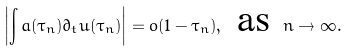Convert formula to latex. <formula><loc_0><loc_0><loc_500><loc_500>\left | \int a ( \tau _ { n } ) \partial _ { t } u ( \tau _ { n } ) \right | = o ( 1 - \tau _ { n } ) , \text { as } n \to \infty .</formula> 